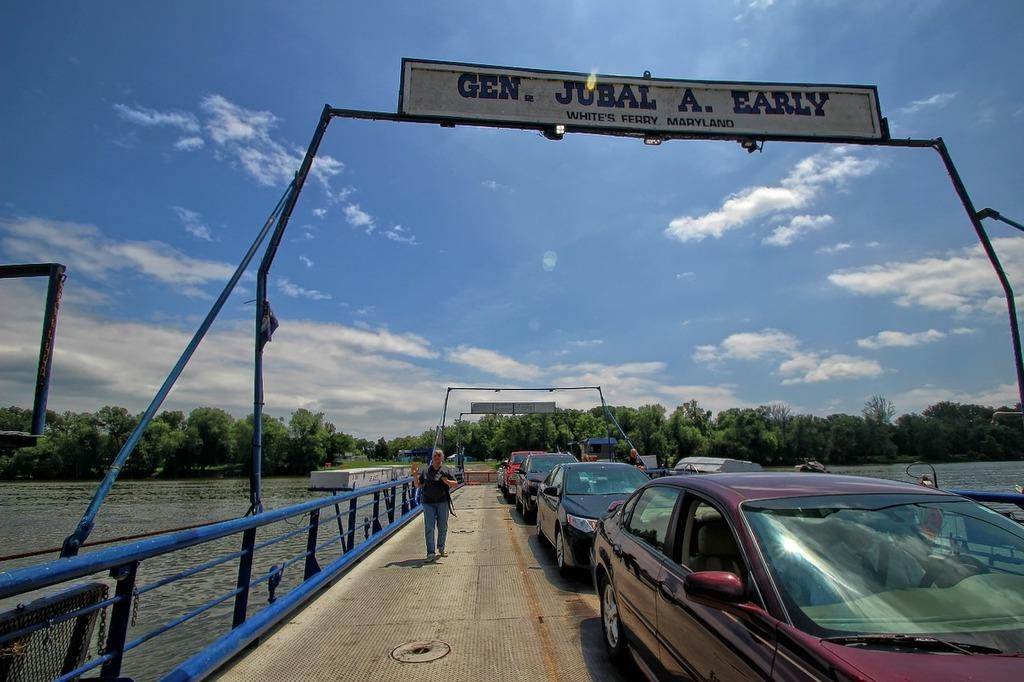Provide a one-sentence caption for the provided image. A line of cars are congested in traffic in White's Ferry, Maryland. 